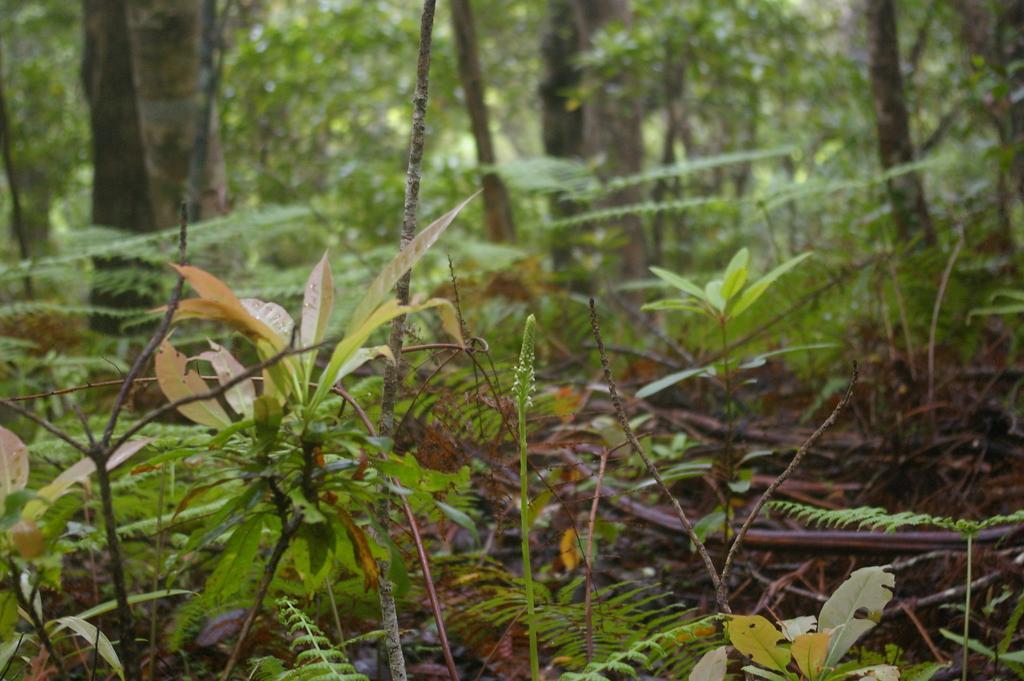Describe this image in one or two sentences. In this image there are four plants in the middle. In the background there are tall trees with green leaves. On the ground there are wooden sticks and small leaves. 